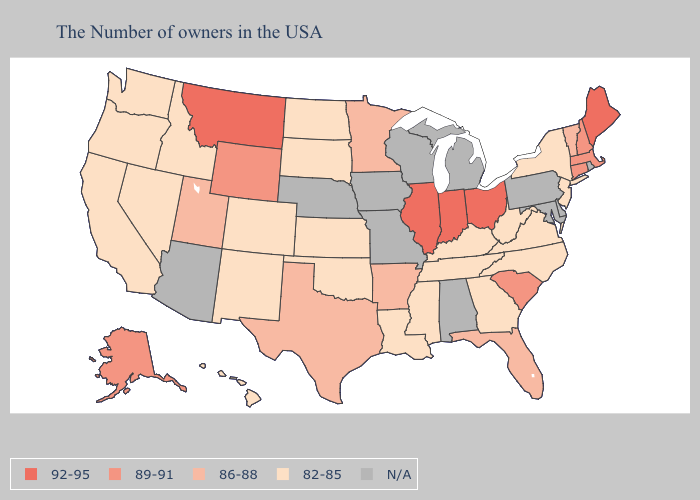Name the states that have a value in the range 86-88?
Give a very brief answer. Vermont, Florida, Arkansas, Minnesota, Texas, Utah. Does Colorado have the highest value in the USA?
Short answer required. No. Does Montana have the highest value in the West?
Answer briefly. Yes. What is the value of New Jersey?
Concise answer only. 82-85. What is the highest value in the USA?
Be succinct. 92-95. What is the lowest value in the USA?
Give a very brief answer. 82-85. How many symbols are there in the legend?
Write a very short answer. 5. What is the value of Mississippi?
Quick response, please. 82-85. What is the value of South Carolina?
Short answer required. 89-91. Does the map have missing data?
Give a very brief answer. Yes. Does Vermont have the lowest value in the Northeast?
Quick response, please. No. What is the value of Oklahoma?
Answer briefly. 82-85. What is the value of Connecticut?
Short answer required. 89-91. Name the states that have a value in the range 89-91?
Keep it brief. Massachusetts, New Hampshire, Connecticut, South Carolina, Wyoming, Alaska. Name the states that have a value in the range 89-91?
Quick response, please. Massachusetts, New Hampshire, Connecticut, South Carolina, Wyoming, Alaska. 